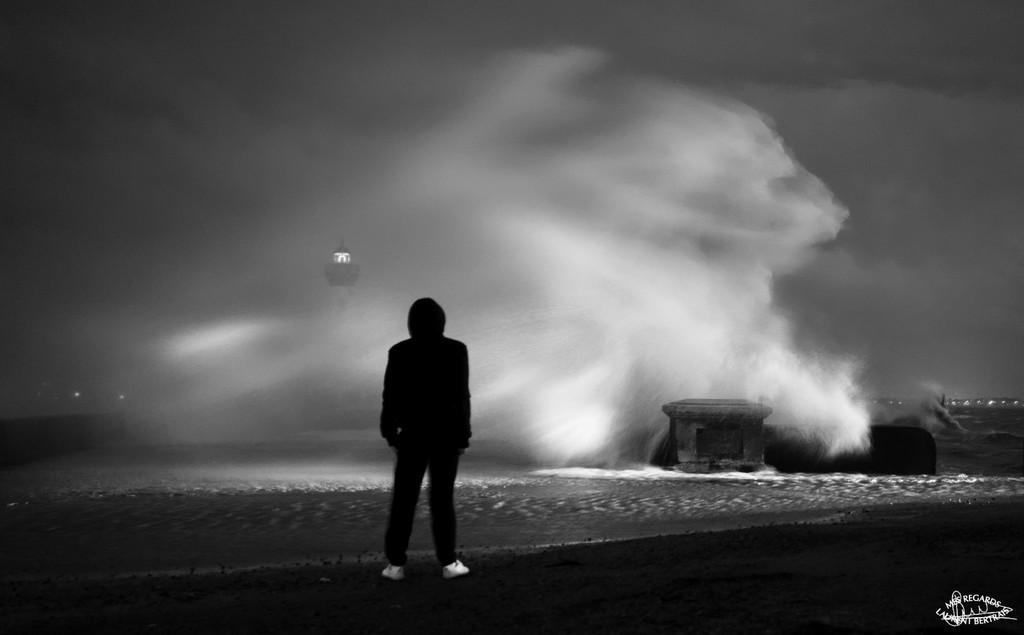Could you give a brief overview of what you see in this image? This is black and white image. On the left side, there is a person standing on the ground. Beside him, there is an ocean. On the bottom right, there is a watermark. In the background, there is a tower, there are tides of the ocean, there are lights and there are clouds in the sky. 